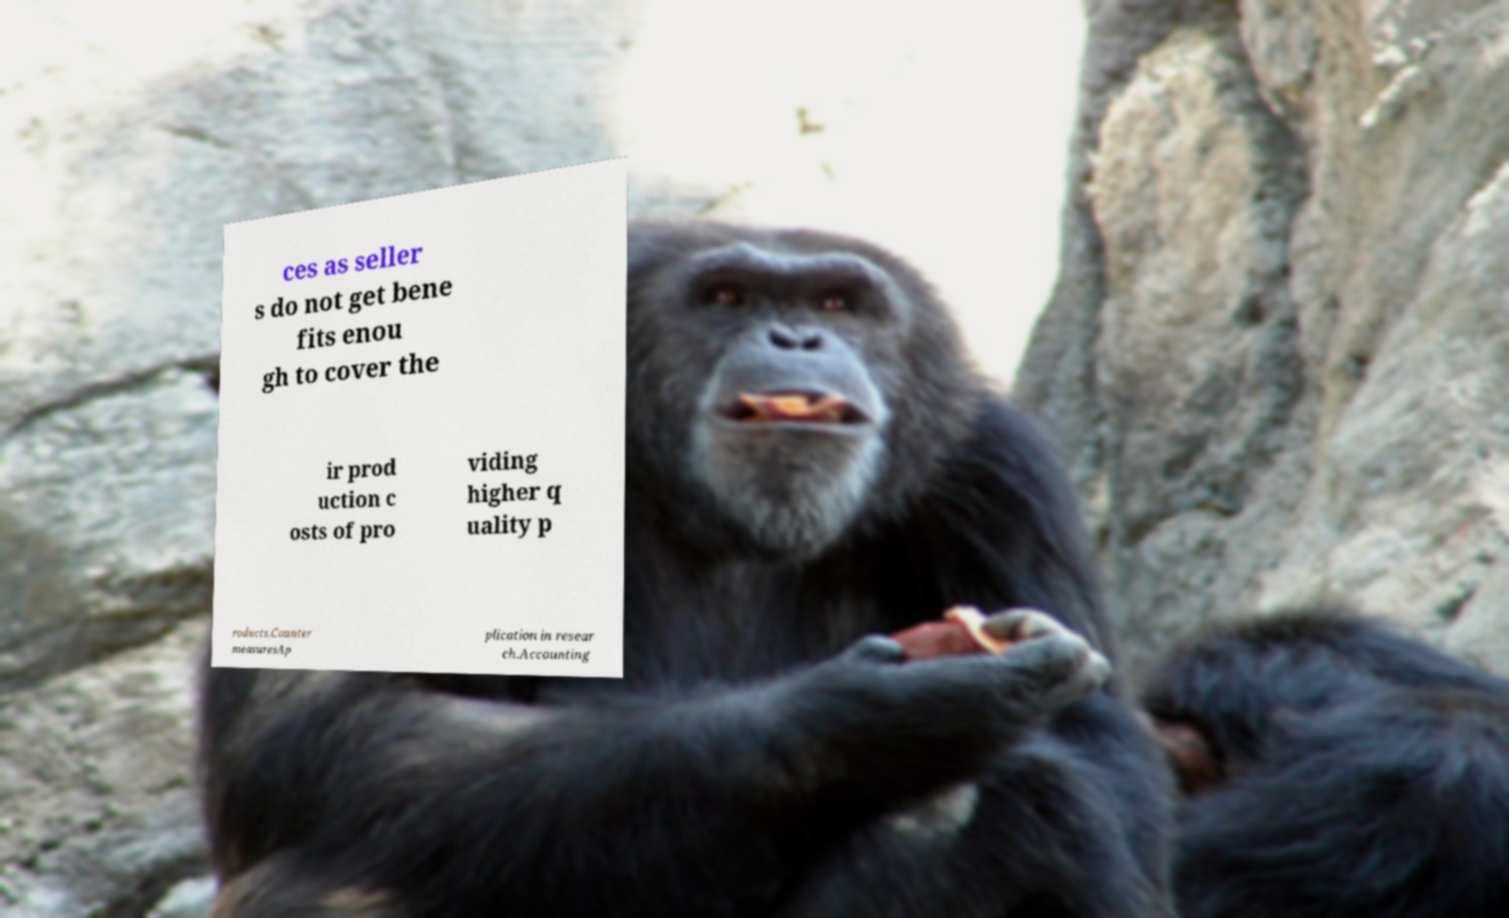For documentation purposes, I need the text within this image transcribed. Could you provide that? ces as seller s do not get bene fits enou gh to cover the ir prod uction c osts of pro viding higher q uality p roducts.Counter measuresAp plication in resear ch.Accounting 